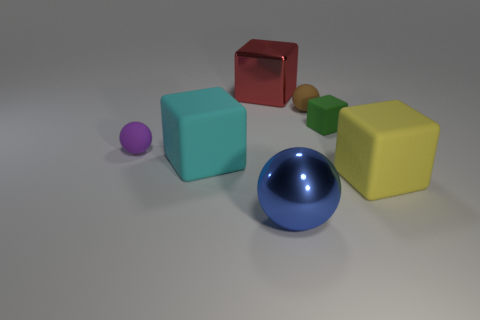What shape is the large rubber object on the left side of the shiny block?
Give a very brief answer. Cube. There is a blue metal object that is the same size as the cyan block; what is its shape?
Provide a succinct answer. Sphere. There is a matte ball that is behind the small sphere to the left of the large block behind the tiny brown rubber sphere; what color is it?
Offer a very short reply. Brown. Does the red object have the same shape as the green rubber thing?
Offer a very short reply. Yes. Is the number of rubber cubes that are to the left of the blue sphere the same as the number of yellow objects?
Your answer should be very brief. Yes. What number of other things are there of the same material as the blue ball
Make the answer very short. 1. Do the matte block behind the cyan block and the matte object to the left of the cyan matte cube have the same size?
Make the answer very short. Yes. How many things are either big rubber things that are left of the big blue shiny sphere or objects behind the large cyan rubber object?
Keep it short and to the point. 5. What number of metal things are either large brown objects or brown balls?
Your answer should be compact. 0. What shape is the large object behind the tiny sphere to the right of the large blue thing?
Offer a terse response. Cube. 